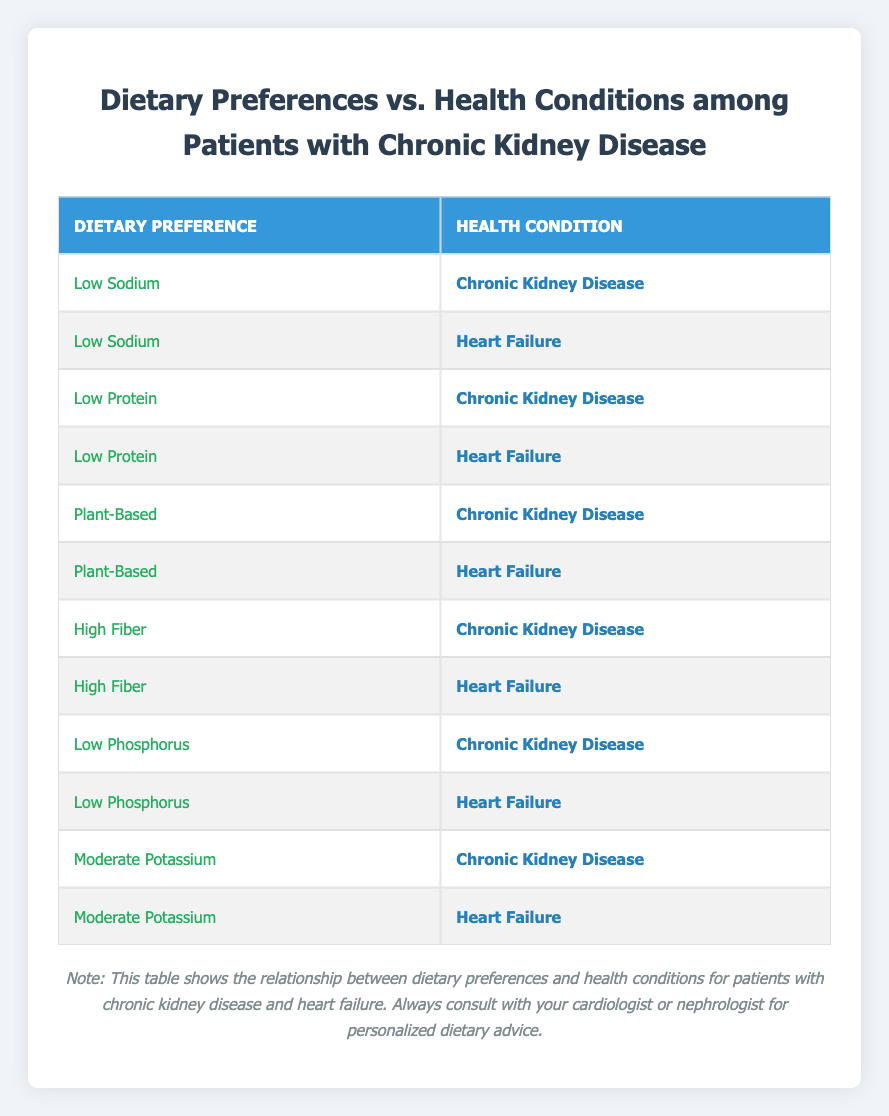What dietary preference is associated with both chronic kidney disease and heart failure? The table lists dietary preferences along with the respective health conditions. By reviewing the rows, "Low Sodium," "Low Protein," "Plant-Based," "High Fiber," "Low Phosphorus," and "Moderate Potassium" are associated with both conditions.
Answer: Low Sodium, Low Protein, Plant-Based, High Fiber, Low Phosphorus, Moderate Potassium Which dietary preference has the highest number of associations with chronic kidney disease? Each dietary preference may have associations with either health condition. Count how many times a dietary preference occurs under "Chronic Kidney Disease." The preferences all appear once, so the count is equal across the board.
Answer: All preferences are equally associated Is there a dietary preference that only appears for chronic kidney disease? Reviewing the table, each dietary preference appears for both chronic kidney disease and heart failure, meaning there are no preferences exclusive to just chronic kidney disease.
Answer: No How many dietary preferences are listed in the table for chronic kidney disease? Count the number of unique dietary preferences that appear under "Chronic Kidney Disease." Upon reviewing the rows, there are a total of six unique preferences indicated.
Answer: 6 Does heart failure have more dietary preferences listed compared to chronic kidney disease? The table contains the same number of dietary preferences listed for both conditions. Each condition has six associated dietary preferences, indicating an equal number in both cases.
Answer: No If I consider only the plant-based diet, how many health conditions does it correspond to? The table shows that "Plant-Based" appears under both chronic kidney disease and heart failure. Therefore, it corresponds to two distinct health conditions as per the data shown.
Answer: 2 Which dietary preference appears most frequently overall in the table? Each dietary preference appears exactly once for each health condition in the table, meaning no preference has a higher frequency than any other. Therefore, all are equally common.
Answer: All preferences are equally frequent If I were to combine the counts of dietary preferences linked to both conditions, how many total associations would there be? There are six dietary preferences for chronic kidney disease and the same six for heart failure. Adding these together gives a total of 12 associations across both conditions in the table.
Answer: 12 Are there any dietary preferences that are exclusively for heart failure? Reviewing the data, it shows that every dietary preference listed in the table has associations with both health conditions. Thus, there are no preferences that are exclusive to heart failure.
Answer: No 